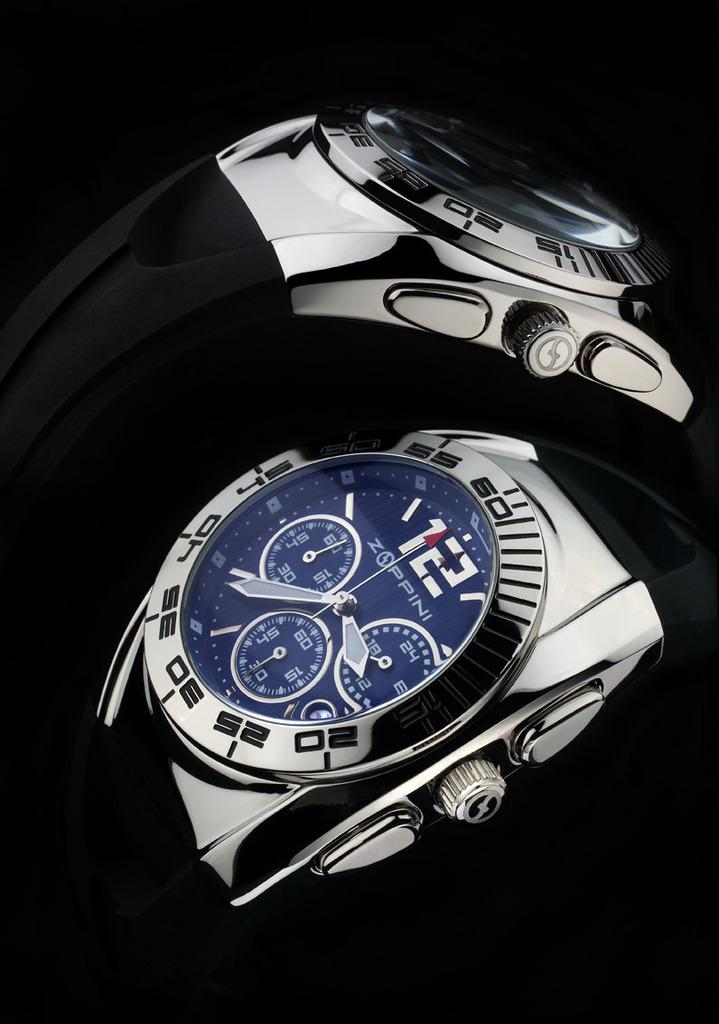<image>
Create a compact narrative representing the image presented. Two watches are together; one is branded "Zoppini". 